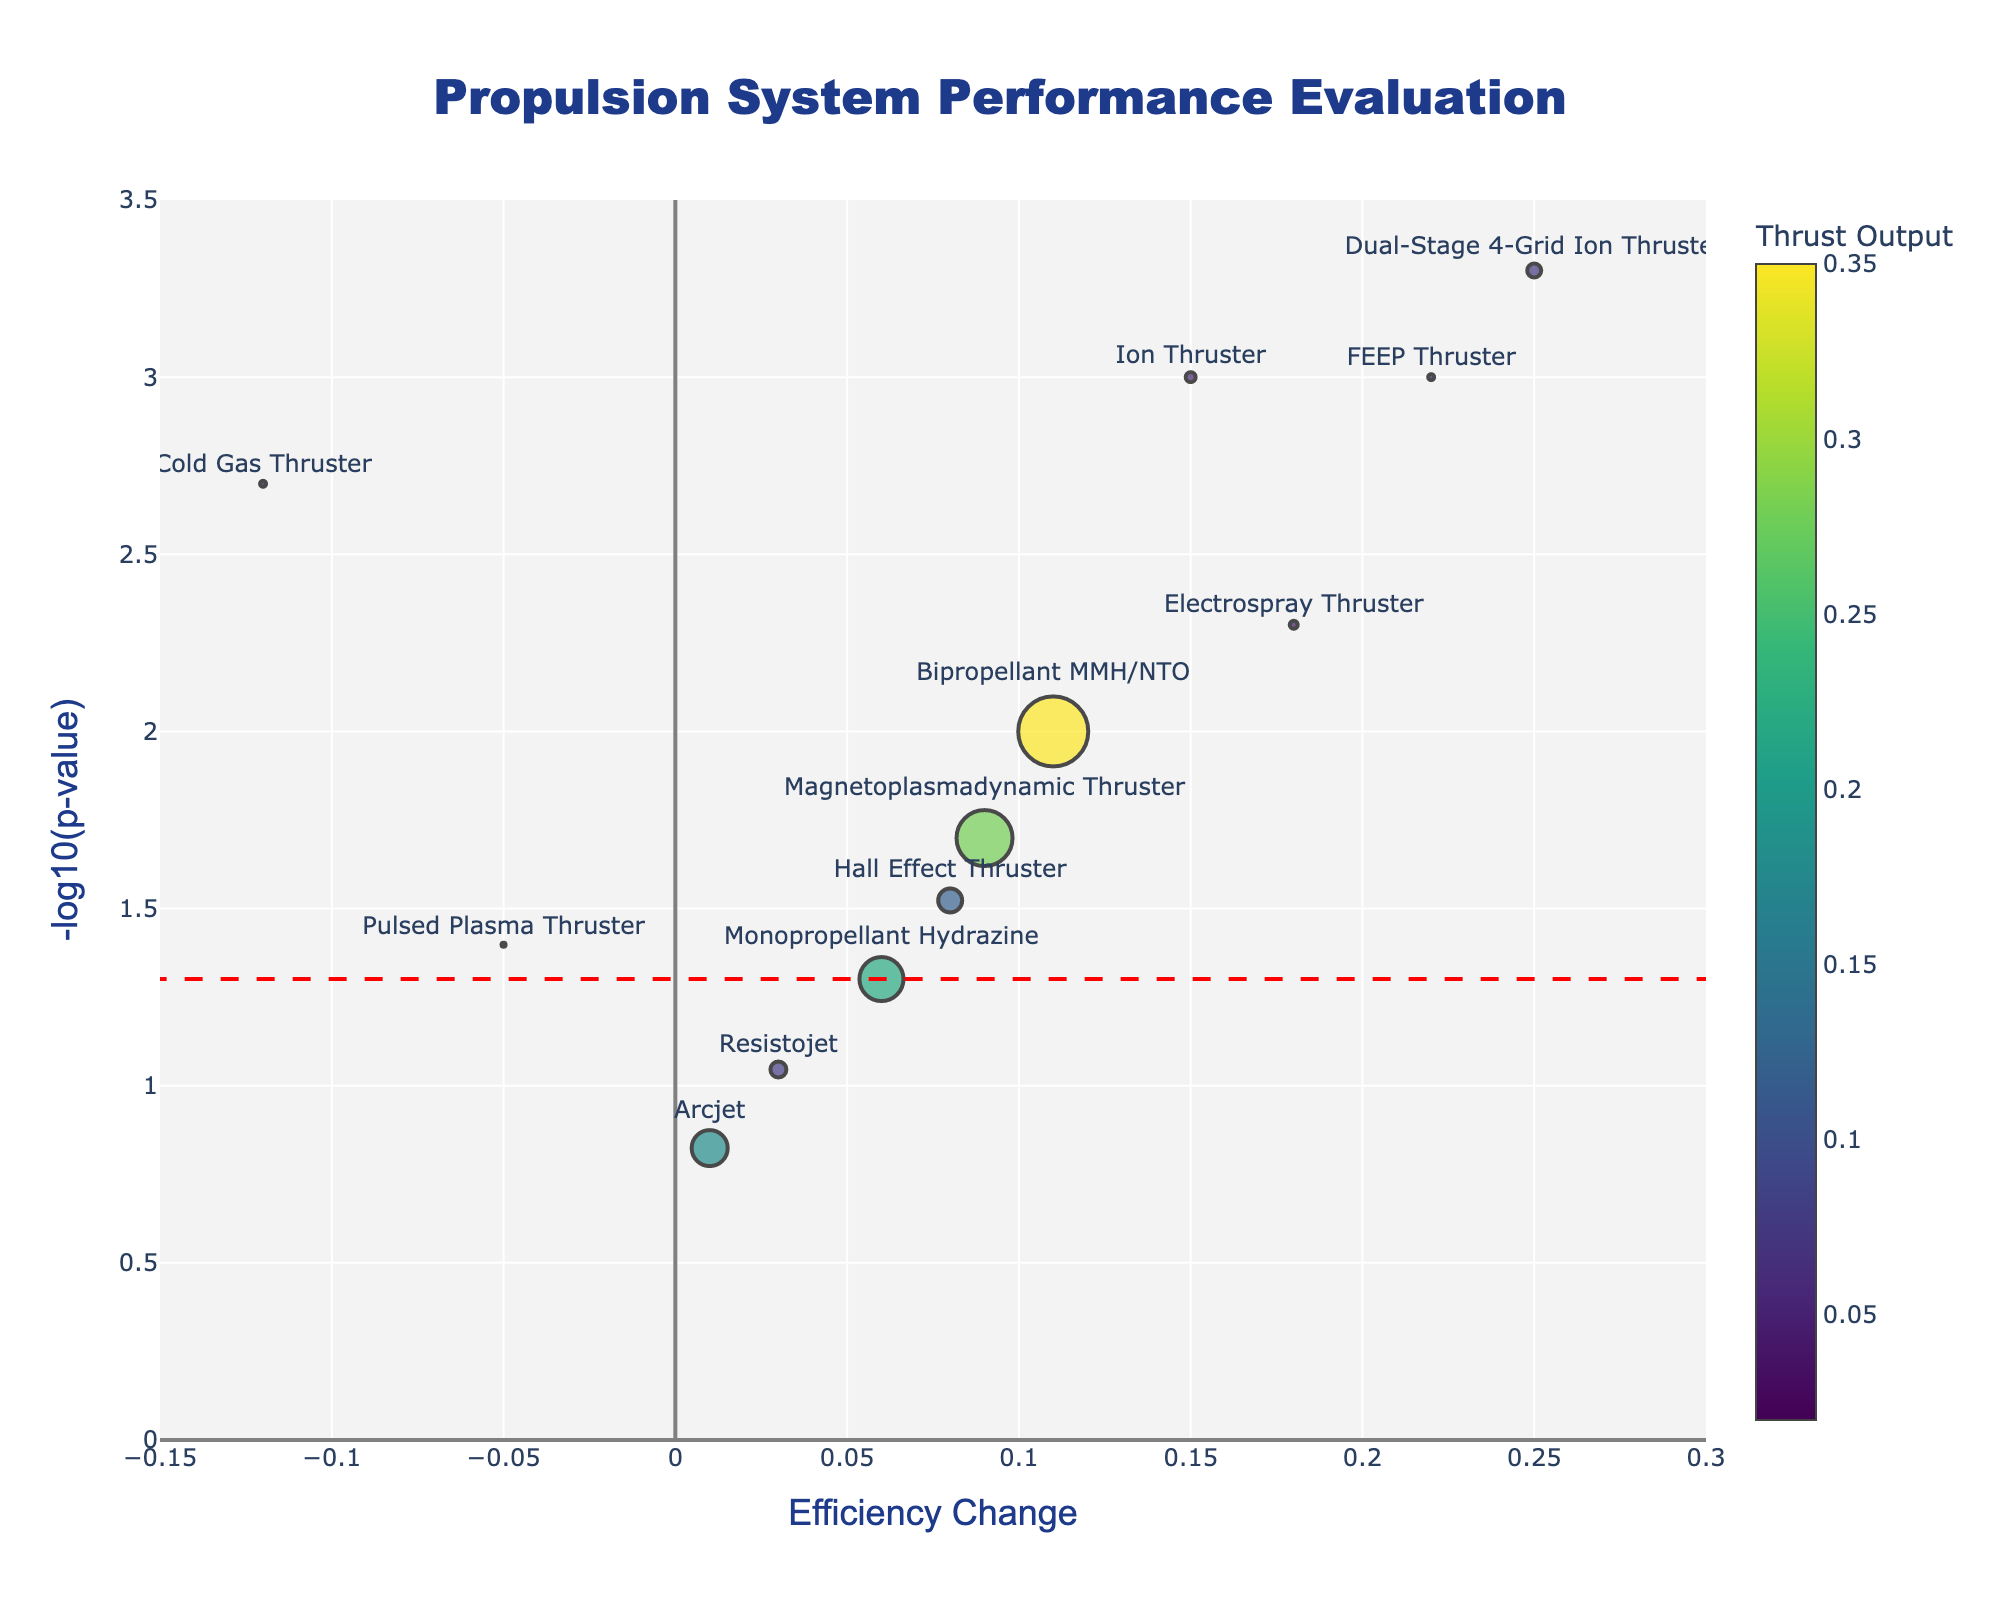What is the title of the plot? The title is displayed at the top center of the plot, which reads "Propulsion System Performance Evaluation".
Answer: Propulsion System Performance Evaluation What are the x and y axes labeled? The x-axis is labeled "Efficiency Change" and the y-axis is labeled "-log10(p-value)". This information is found along the respective axes of the plot.
Answer: Efficiency Change; -log10(p-value) How many propulsion systems have a positive efficiency change? To find this, count the markers (data points) to the right of the x-axis (Efficiency Change) where values are greater than 0. Count these data points.
Answer: 9 Which propulsion system has the highest efficiency change? By looking at the rightmost data point on the x-axis (Efficiency Change), we see it is labeled as the "Dual-Stage 4-Grid Ion Thruster".
Answer: Dual-Stage 4-Grid Ion Thruster Which propulsion systems have p-values less than 0.05? Identify the points with y-values greater than -log10(0.05). The corresponding propulsion systems are found by checking the hover text for those points.
Answer: Ion Thruster, Cold Gas Thruster, Electrospray Thruster, FEEP Thruster, Hall Effect Thruster, Bipropellant MMH/NTO, Magnetoplasmadynamic Thruster How does the thrust output of the Ion Thruster compare to the Hall Effect Thruster? By examining the size of the markers: the Ion Thruster marker is smaller than the Hall Effect Thruster marker, indicating a lower thrust output.
Answer: Hall Effect Thruster has higher thrust Which propulsion system has the largest marker size, and what does it indicate? The largest marker size indicates the highest thrust output. The Bipropellant MMH/NTO has the largest marker size on the plot.
Answer: Bipropellant MMH/NTO Are there any propulsion systems with negative efficiency change and statistically significant p-values? Check for markers on the left side of the Efficiency Change axis (x < 0) with y-values greater than -log10(0.05). One such system is the Cold Gas Thruster.
Answer: Cold Gas Thruster What do the colors of the markers represent, and which color corresponds to the highest thrust output? The color scale represents the thrust output. The color bar next to the plot indicates that the brightest colors represent higher thrust outputs, so the largest marker (Bipropellant MMH/NTO) would have the brightest color.
Answer: Thrust output; Brightest color What threshold is indicated by the red dashed line, and how many systems fall above this line? The red dashed line represents a p-value of 0.05 on the -log10(p-value) scale. Count the markers above this line, as their y-values would be greater than -log10(0.05).
Answer: Significance threshold (p=0.05); 7 systems 